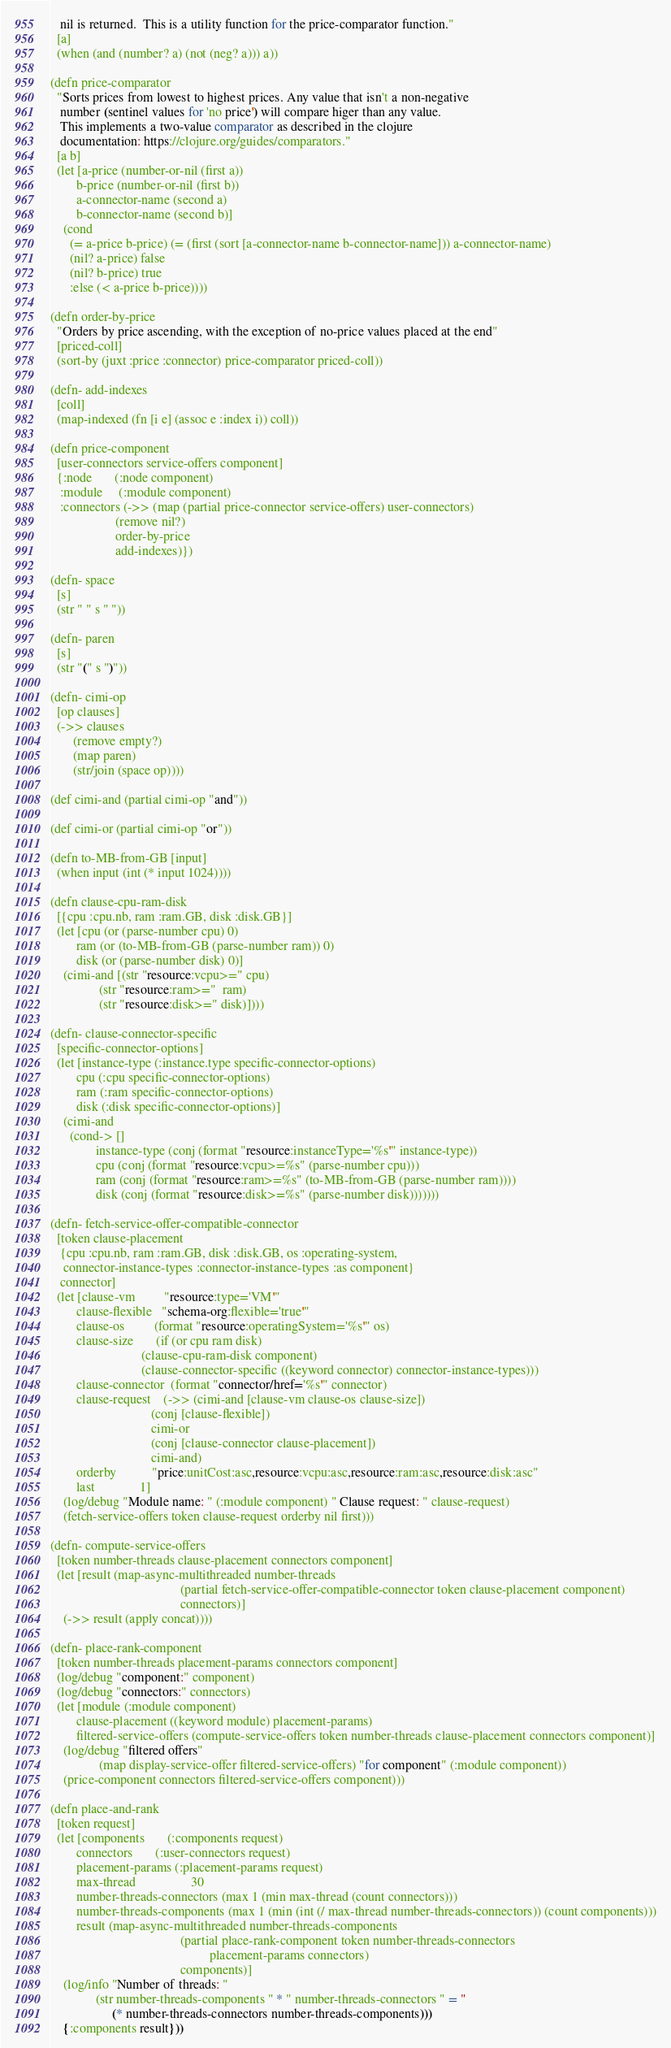<code> <loc_0><loc_0><loc_500><loc_500><_Clojure_>   nil is returned.  This is a utility function for the price-comparator function."
  [a]
  (when (and (number? a) (not (neg? a))) a))

(defn price-comparator
  "Sorts prices from lowest to highest prices. Any value that isn't a non-negative
   number (sentinel values for 'no price') will compare higer than any value.
   This implements a two-value comparator as described in the clojure
   documentation: https://clojure.org/guides/comparators."
  [a b]
  (let [a-price (number-or-nil (first a))
        b-price (number-or-nil (first b))
        a-connector-name (second a)
        b-connector-name (second b)]
    (cond
      (= a-price b-price) (= (first (sort [a-connector-name b-connector-name])) a-connector-name)
      (nil? a-price) false
      (nil? b-price) true
      :else (< a-price b-price))))

(defn order-by-price
  "Orders by price ascending, with the exception of no-price values placed at the end"
  [priced-coll]
  (sort-by (juxt :price :connector) price-comparator priced-coll))

(defn- add-indexes
  [coll]
  (map-indexed (fn [i e] (assoc e :index i)) coll))

(defn price-component
  [user-connectors service-offers component]
  {:node       (:node component)
   :module     (:module component)
   :connectors (->> (map (partial price-connector service-offers) user-connectors)
                    (remove nil?)
                    order-by-price
                    add-indexes)})

(defn- space
  [s]
  (str " " s " "))

(defn- paren
  [s]
  (str "(" s ")"))

(defn- cimi-op
  [op clauses]
  (->> clauses
       (remove empty?)
       (map paren)
       (str/join (space op))))

(def cimi-and (partial cimi-op "and"))

(def cimi-or (partial cimi-op "or"))

(defn to-MB-from-GB [input]
  (when input (int (* input 1024))))

(defn clause-cpu-ram-disk
  [{cpu :cpu.nb, ram :ram.GB, disk :disk.GB}]
  (let [cpu (or (parse-number cpu) 0)
        ram (or (to-MB-from-GB (parse-number ram)) 0)
        disk (or (parse-number disk) 0)]
    (cimi-and [(str "resource:vcpu>=" cpu)
               (str "resource:ram>="  ram)
               (str "resource:disk>=" disk)])))

(defn- clause-connector-specific
  [specific-connector-options]
  (let [instance-type (:instance.type specific-connector-options)
        cpu (:cpu specific-connector-options)
        ram (:ram specific-connector-options)
        disk (:disk specific-connector-options)]
    (cimi-and
      (cond-> []
              instance-type (conj (format "resource:instanceType='%s'" instance-type))
              cpu (conj (format "resource:vcpu>=%s" (parse-number cpu)))
              ram (conj (format "resource:ram>=%s" (to-MB-from-GB (parse-number ram))))
              disk (conj (format "resource:disk>=%s" (parse-number disk)))))))

(defn- fetch-service-offer-compatible-connector
  [token clause-placement
   {cpu :cpu.nb, ram :ram.GB, disk :disk.GB, os :operating-system,
    connector-instance-types :connector-instance-types :as component}
   connector]
  (let [clause-vm         "resource:type='VM'"
        clause-flexible   "schema-org:flexible='true'"
        clause-os         (format "resource:operatingSystem='%s'" os)
        clause-size       (if (or cpu ram disk)
                            (clause-cpu-ram-disk component)
                            (clause-connector-specific ((keyword connector) connector-instance-types)))
        clause-connector  (format "connector/href='%s'" connector)
        clause-request    (->> (cimi-and [clause-vm clause-os clause-size])
                               (conj [clause-flexible])
                               cimi-or
                               (conj [clause-connector clause-placement])
                               cimi-and)
        orderby           "price:unitCost:asc,resource:vcpu:asc,resource:ram:asc,resource:disk:asc"
        last              1]
    (log/debug "Module name: " (:module component) " Clause request: " clause-request)
    (fetch-service-offers token clause-request orderby nil first)))

(defn- compute-service-offers
  [token number-threads clause-placement connectors component]
  (let [result (map-async-multithreaded number-threads
                                        (partial fetch-service-offer-compatible-connector token clause-placement component)
                                        connectors)]
    (->> result (apply concat))))

(defn- place-rank-component
  [token number-threads placement-params connectors component]
  (log/debug "component:" component)
  (log/debug "connectors:" connectors)
  (let [module (:module component)
        clause-placement ((keyword module) placement-params)
        filtered-service-offers (compute-service-offers token number-threads clause-placement connectors component)]
    (log/debug "filtered offers"
               (map display-service-offer filtered-service-offers) "for component" (:module component))
    (price-component connectors filtered-service-offers component)))

(defn place-and-rank
  [token request]
  (let [components       (:components request)
        connectors       (:user-connectors request)
        placement-params (:placement-params request)
        max-thread                 30
        number-threads-connectors (max 1 (min max-thread (count connectors)))
        number-threads-components (max 1 (min (int (/ max-thread number-threads-connectors)) (count components)))
        result (map-async-multithreaded number-threads-components
                                        (partial place-rank-component token number-threads-connectors
                                                 placement-params connectors)
                                        components)]
    (log/info "Number of threads: "
              (str number-threads-components " * " number-threads-connectors " = "
                   (* number-threads-connectors number-threads-components)))
    {:components result}))
</code> 